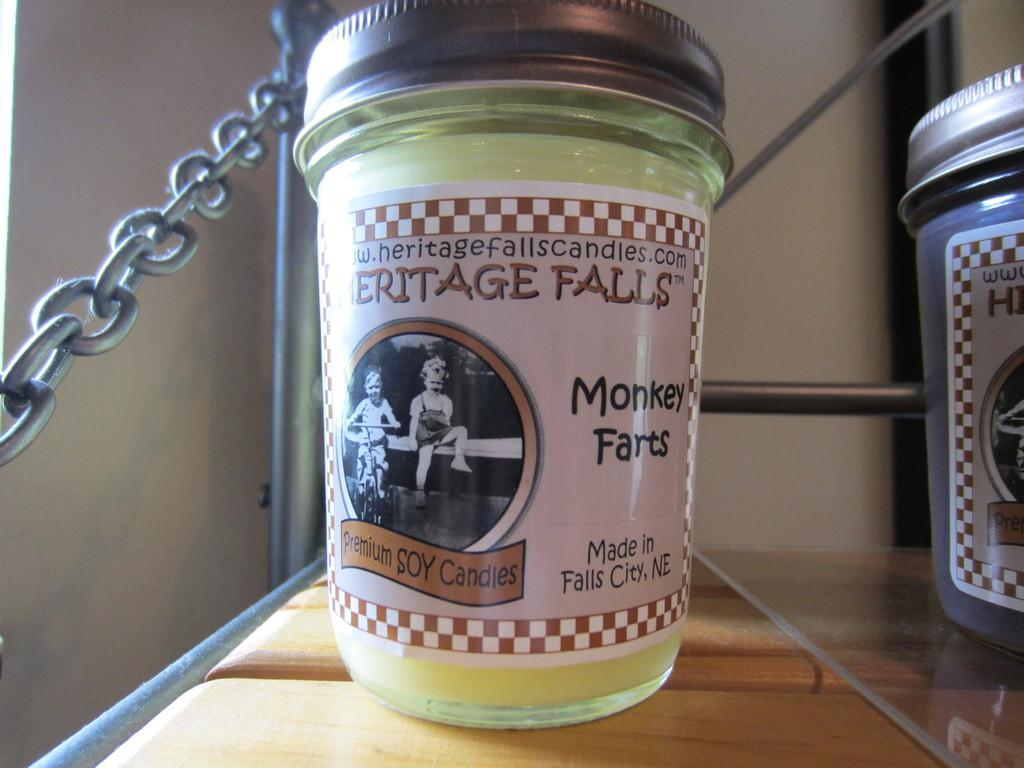<image>
Write a terse but informative summary of the picture. A candle from Heritage Falls called Monkey Farts 